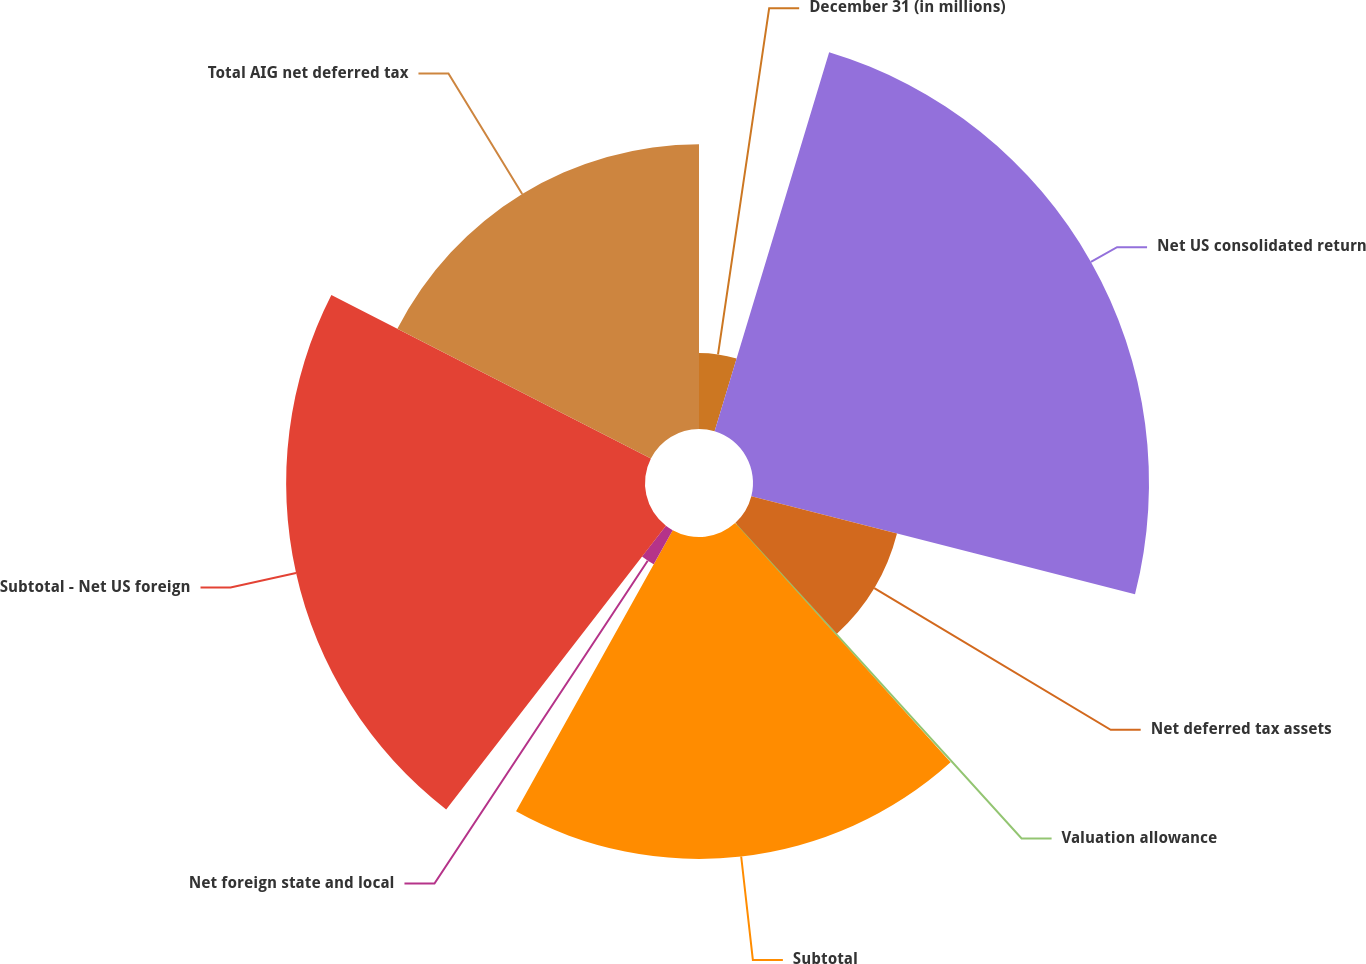Convert chart. <chart><loc_0><loc_0><loc_500><loc_500><pie_chart><fcel>December 31 (in millions)<fcel>Net US consolidated return<fcel>Net deferred tax assets<fcel>Valuation allowance<fcel>Subtotal<fcel>Net foreign state and local<fcel>Subtotal - Net US foreign<fcel>Total AIG net deferred tax<nl><fcel>4.67%<fcel>24.31%<fcel>9.23%<fcel>0.12%<fcel>19.76%<fcel>2.4%<fcel>22.03%<fcel>17.48%<nl></chart> 